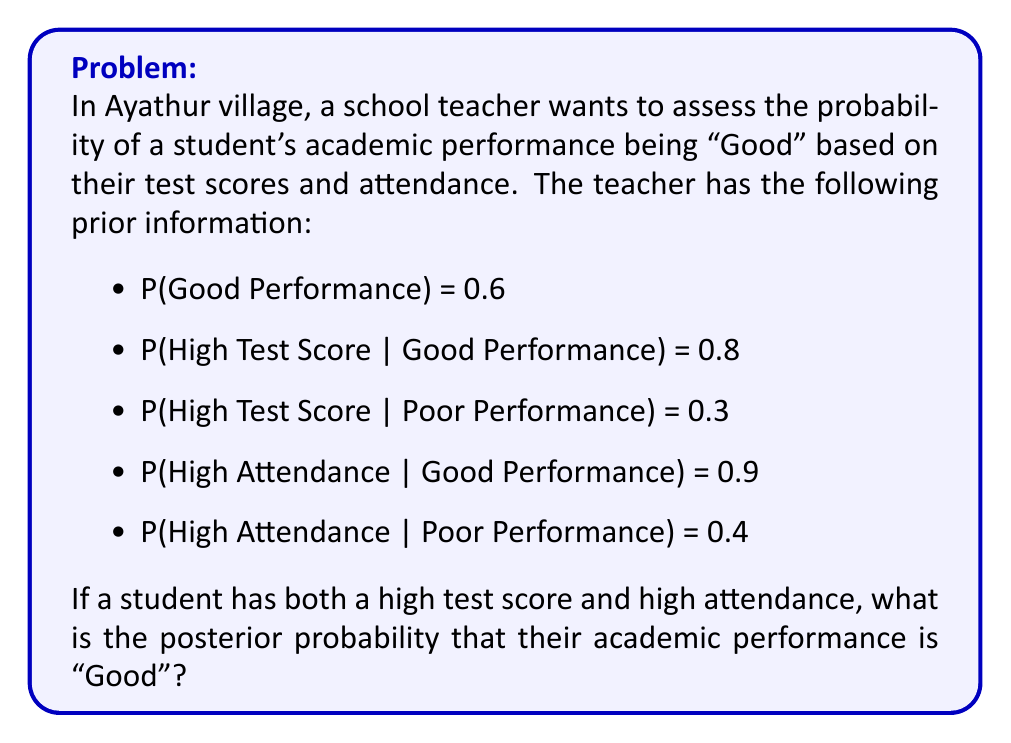Solve this math problem. To solve this problem, we'll use Bayes' theorem. Let's define our events:

G: Good Performance
H: High Test Score
A: High Attendance

We want to find P(G | H, A).

Step 1: Write out Bayes' theorem for this scenario:

$$ P(G | H, A) = \frac{P(H, A | G) \cdot P(G)}{P(H, A)} $$

Step 2: Calculate P(H, A | G):
Assuming independence between test scores and attendance given performance:

$$ P(H, A | G) = P(H | G) \cdot P(A | G) = 0.8 \cdot 0.9 = 0.72 $$

Step 3: Calculate P(H, A):
We can use the law of total probability:

$$ P(H, A) = P(H, A | G) \cdot P(G) + P(H, A | \text{not G}) \cdot P(\text{not G}) $$

$$ P(H, A) = 0.72 \cdot 0.6 + (0.3 \cdot 0.4) \cdot 0.4 = 0.432 + 0.048 = 0.48 $$

Step 4: Apply Bayes' theorem:

$$ P(G | H, A) = \frac{0.72 \cdot 0.6}{0.48} = \frac{0.432}{0.48} = 0.9 $$

Therefore, the posterior probability of Good Performance given High Test Score and High Attendance is 0.9 or 90%.
Answer: The posterior probability that the student's academic performance is "Good" given both high test score and high attendance is 0.9 or 90%. 